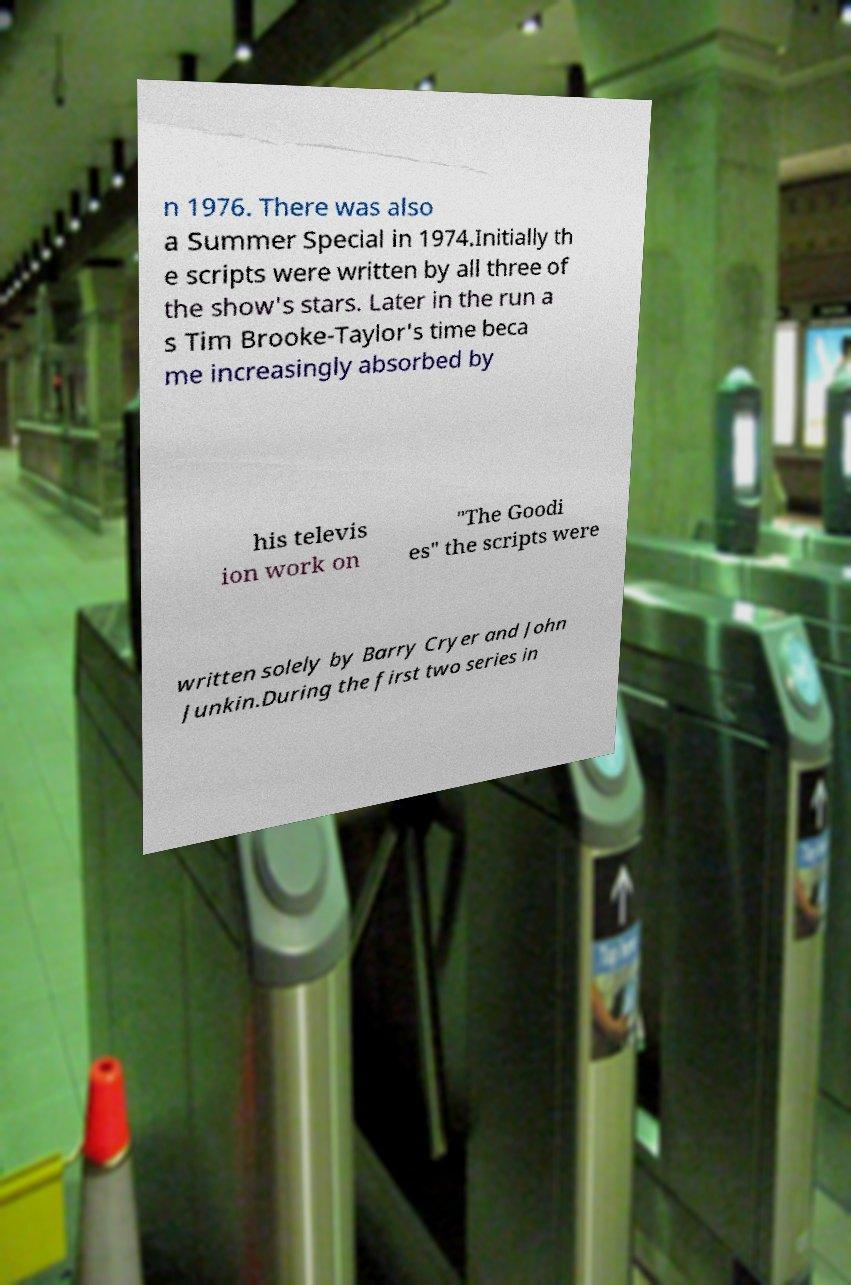Could you assist in decoding the text presented in this image and type it out clearly? n 1976. There was also a Summer Special in 1974.Initially th e scripts were written by all three of the show's stars. Later in the run a s Tim Brooke-Taylor's time beca me increasingly absorbed by his televis ion work on "The Goodi es" the scripts were written solely by Barry Cryer and John Junkin.During the first two series in 